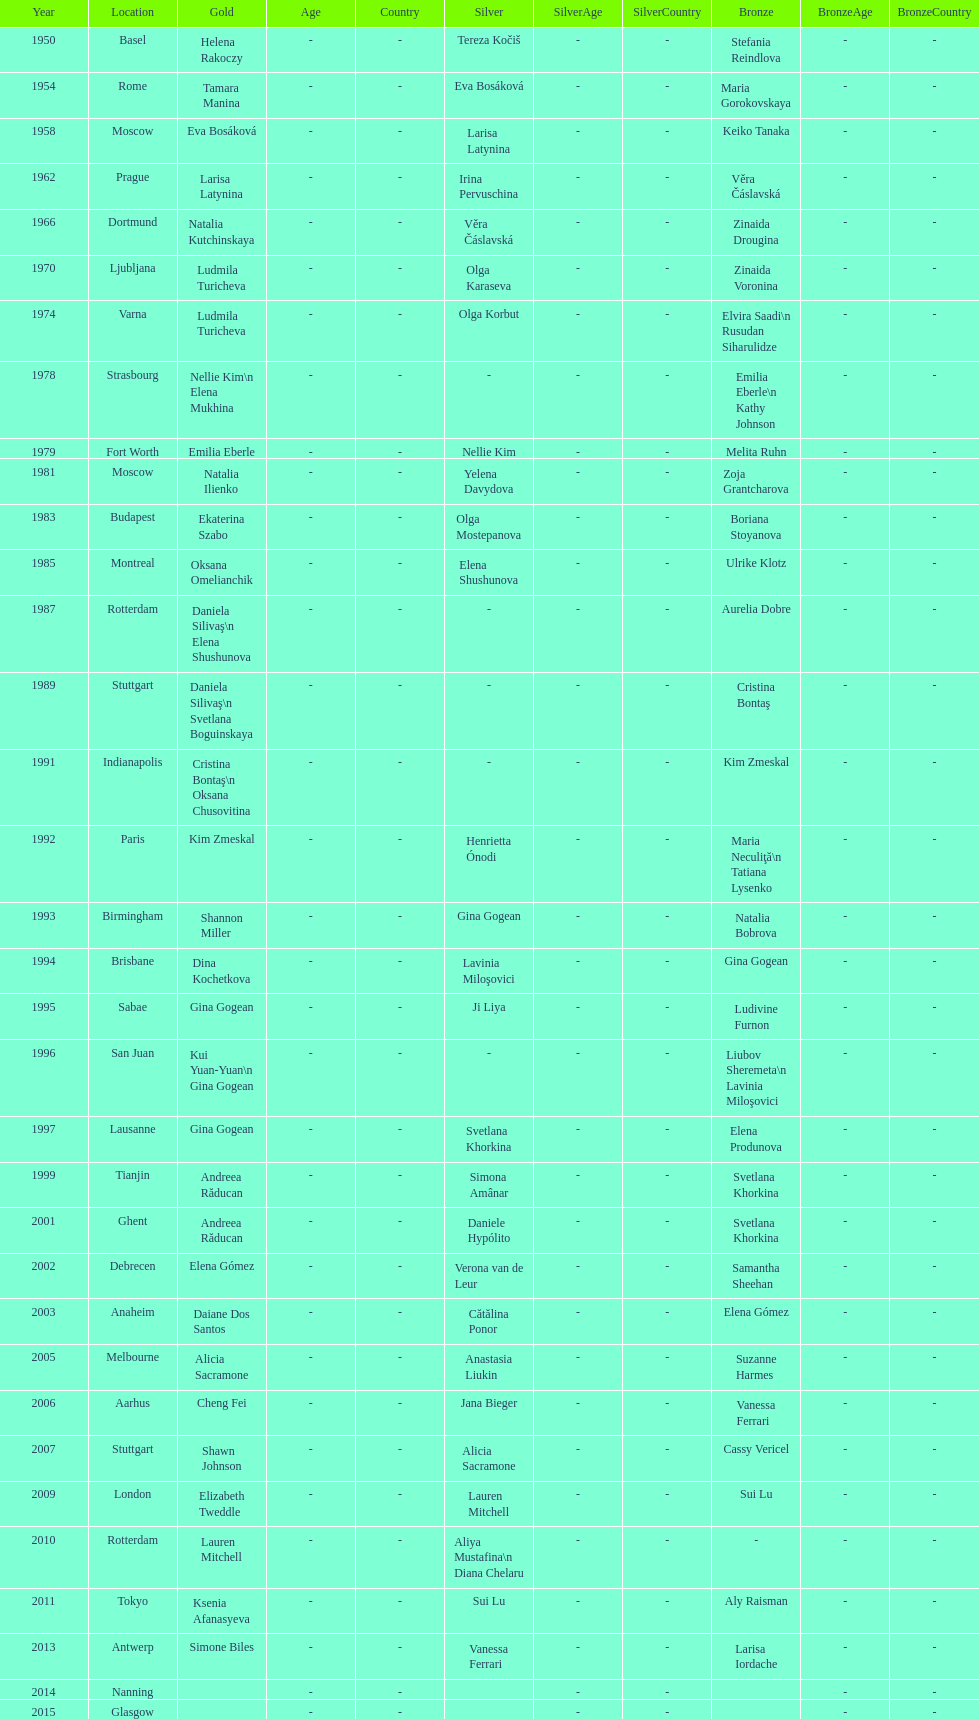What is the number of times a brazilian has won a medal? 2. 